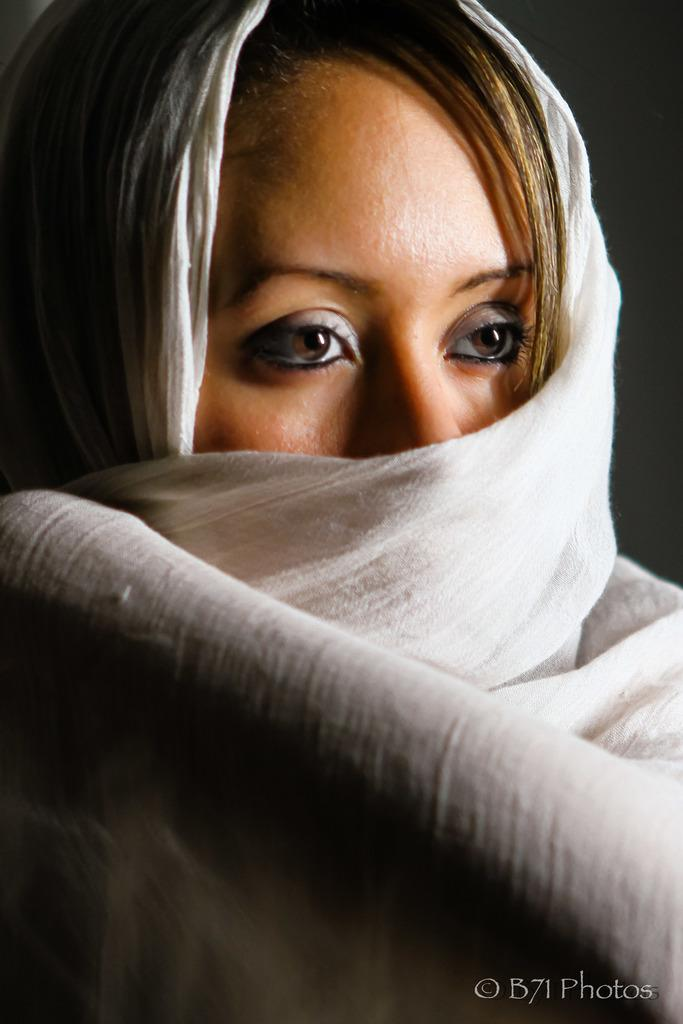Who is the main subject in the image? There is a woman in the image. What is the woman wearing around her neck? The woman is wearing a white scarf. In which direction is the woman looking? The woman is looking to the right. What can be found in the bottom right corner of the image? There is text in the bottom right corner of the image. What color is the background of the image? The background of the image is black. What type of songs can be heard playing in the background of the image? There is no audio or music present in the image, so it is not possible to determine what songs might be heard. 